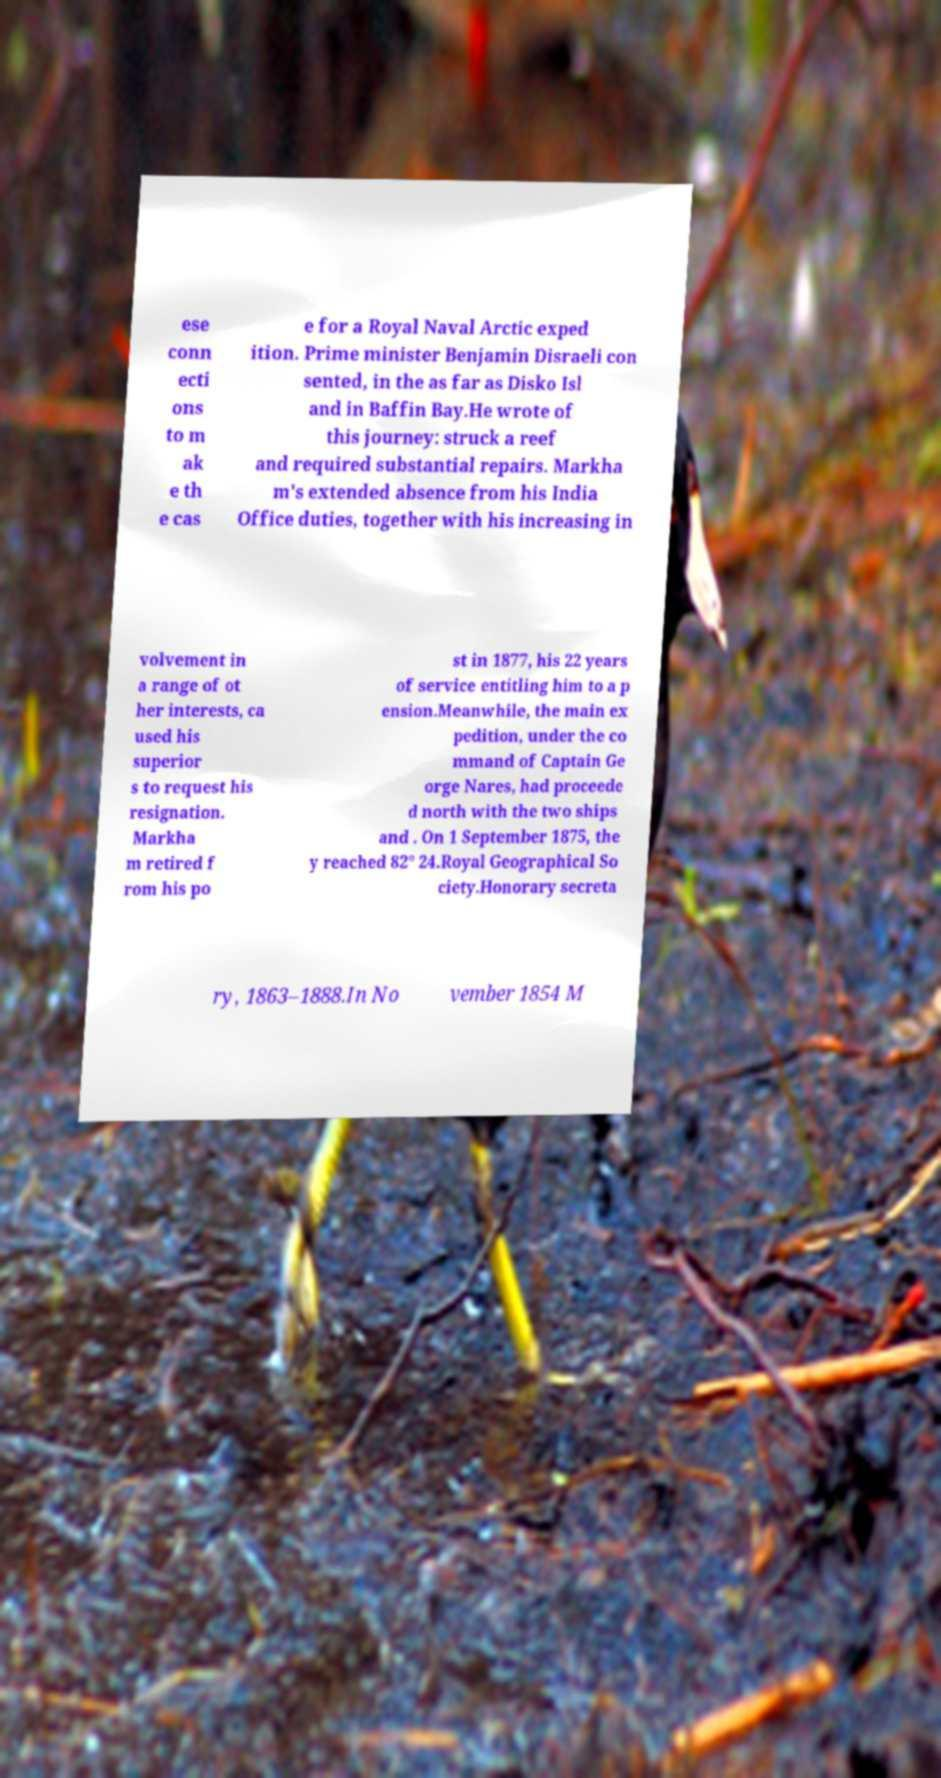Could you extract and type out the text from this image? ese conn ecti ons to m ak e th e cas e for a Royal Naval Arctic exped ition. Prime minister Benjamin Disraeli con sented, in the as far as Disko Isl and in Baffin Bay.He wrote of this journey: struck a reef and required substantial repairs. Markha m's extended absence from his India Office duties, together with his increasing in volvement in a range of ot her interests, ca used his superior s to request his resignation. Markha m retired f rom his po st in 1877, his 22 years of service entitling him to a p ension.Meanwhile, the main ex pedition, under the co mmand of Captain Ge orge Nares, had proceede d north with the two ships and . On 1 September 1875, the y reached 82° 24.Royal Geographical So ciety.Honorary secreta ry, 1863–1888.In No vember 1854 M 